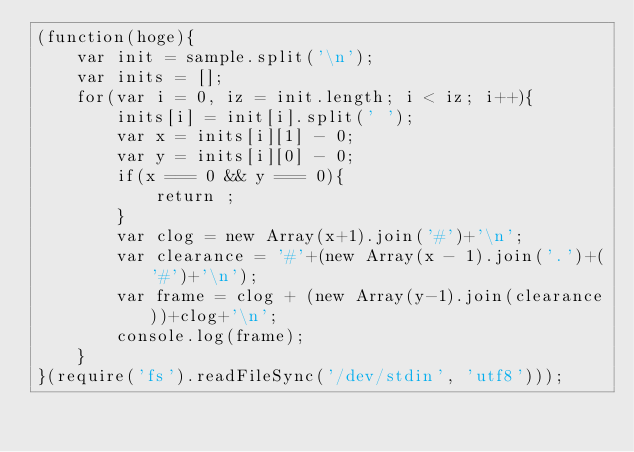Convert code to text. <code><loc_0><loc_0><loc_500><loc_500><_JavaScript_>(function(hoge){
    var init = sample.split('\n');
    var inits = [];
    for(var i = 0, iz = init.length; i < iz; i++){
        inits[i] = init[i].split(' ');
        var x = inits[i][1] - 0;
        var y = inits[i][0] - 0;
        if(x === 0 && y === 0){
            return ;
        }
        var clog = new Array(x+1).join('#')+'\n';
        var clearance = '#'+(new Array(x - 1).join('.')+('#')+'\n');
        var frame = clog + (new Array(y-1).join(clearance))+clog+'\n';
        console.log(frame);
    }
}(require('fs').readFileSync('/dev/stdin', 'utf8')));</code> 